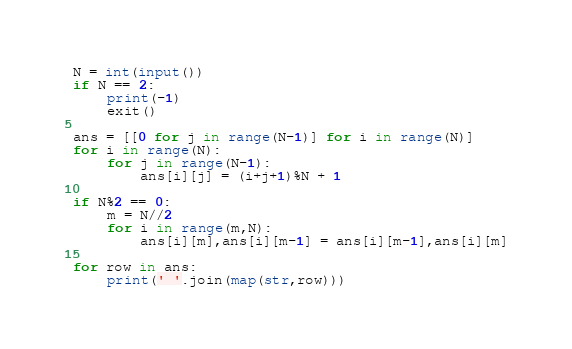<code> <loc_0><loc_0><loc_500><loc_500><_Python_>N = int(input())
if N == 2:
    print(-1)
    exit()

ans = [[0 for j in range(N-1)] for i in range(N)]
for i in range(N):
    for j in range(N-1):
        ans[i][j] = (i+j+1)%N + 1

if N%2 == 0:
    m = N//2
    for i in range(m,N):
        ans[i][m],ans[i][m-1] = ans[i][m-1],ans[i][m]

for row in ans:
    print(' '.join(map(str,row)))
</code> 